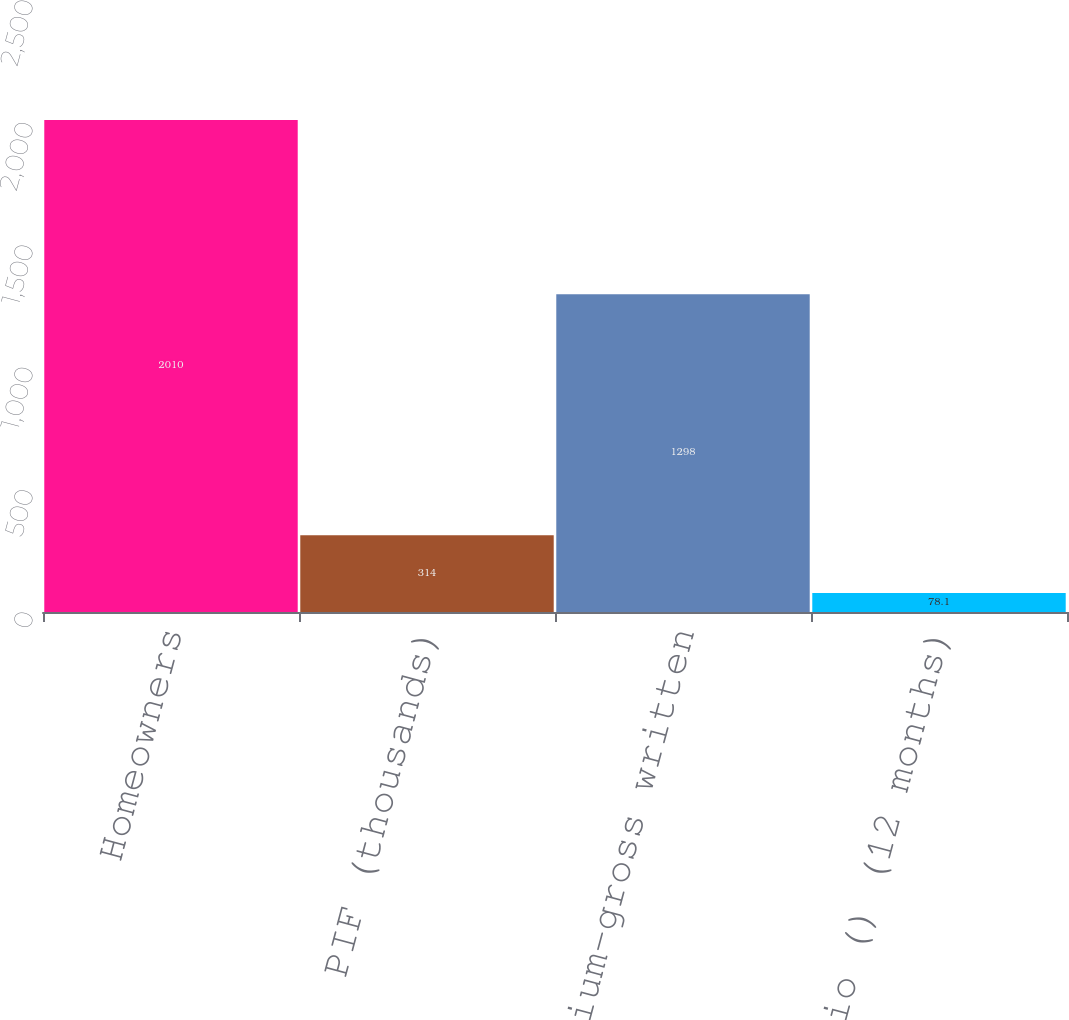Convert chart to OTSL. <chart><loc_0><loc_0><loc_500><loc_500><bar_chart><fcel>Homeowners<fcel>PIF (thousands)<fcel>Average premium-gross written<fcel>Renewal ratio () (12 months)<nl><fcel>2010<fcel>314<fcel>1298<fcel>78.1<nl></chart> 